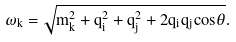Convert formula to latex. <formula><loc_0><loc_0><loc_500><loc_500>\omega _ { k } = \sqrt { m _ { k } ^ { 2 } + q _ { i } ^ { 2 } + q _ { j } ^ { 2 } + 2 q _ { i } q _ { j } { \cos } \theta } .</formula> 